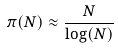Convert formula to latex. <formula><loc_0><loc_0><loc_500><loc_500>\pi ( N ) \approx \frac { N } { \log ( N ) }</formula> 